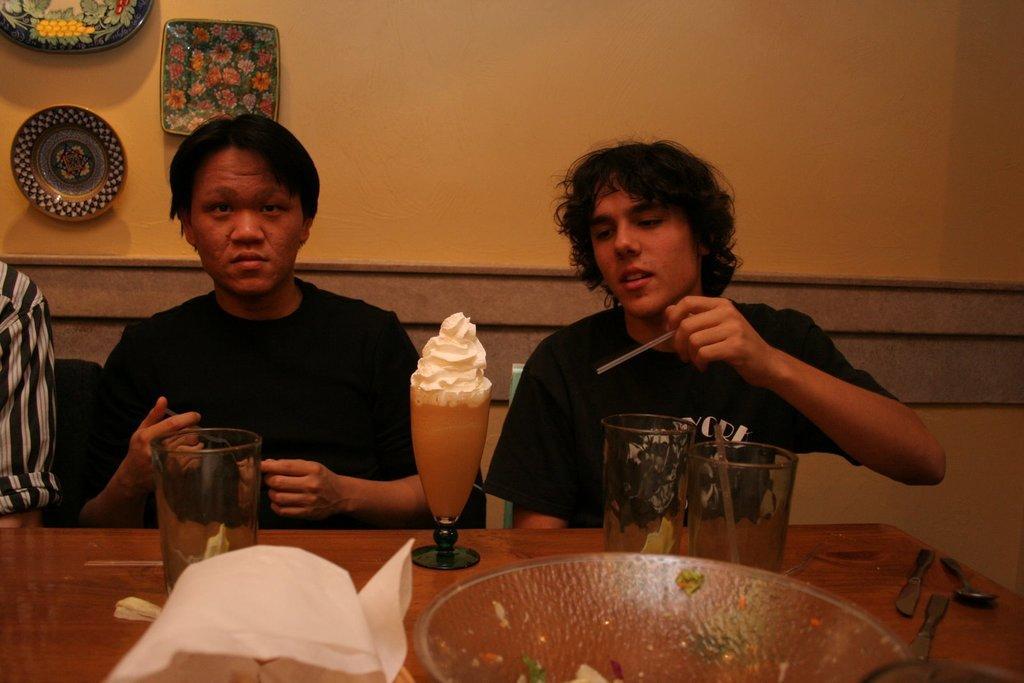Describe this image in one or two sentences. There is a man sitting on a chair on the right side and he is having a ice cream. There is a person on the right side and he is looking at something. This is a wooden table where a glass, an ice cream, a spoon and a bowl are kept on it. 